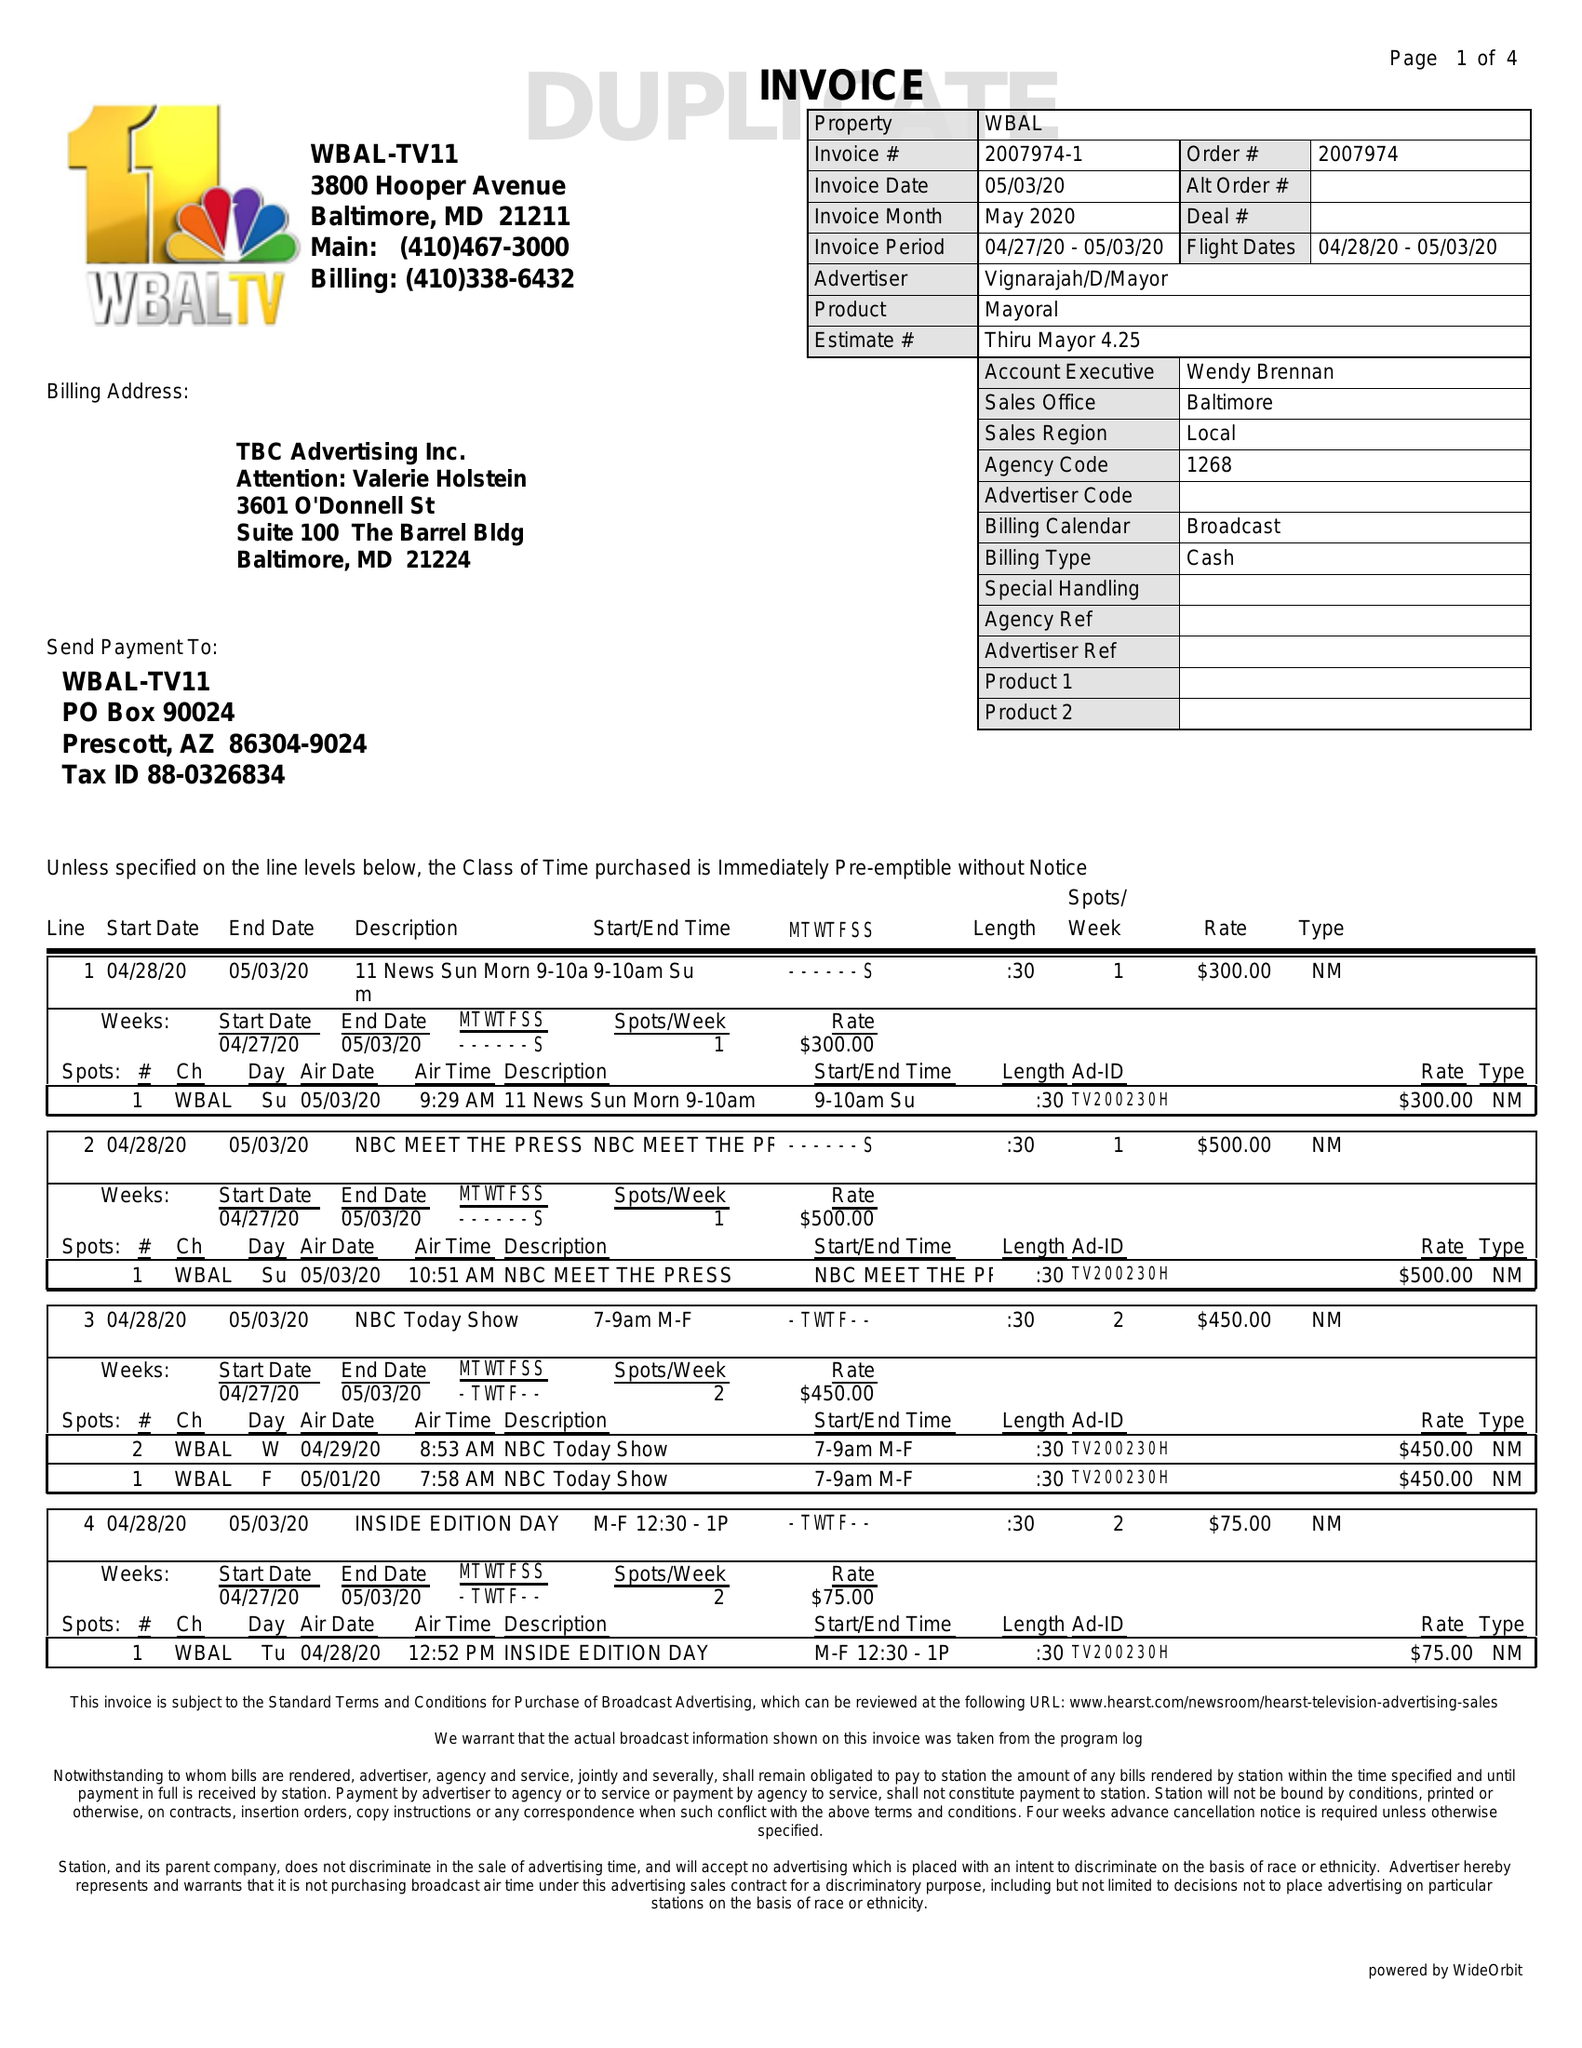What is the value for the advertiser?
Answer the question using a single word or phrase. VIGNARAJAH/D/MAYOR 